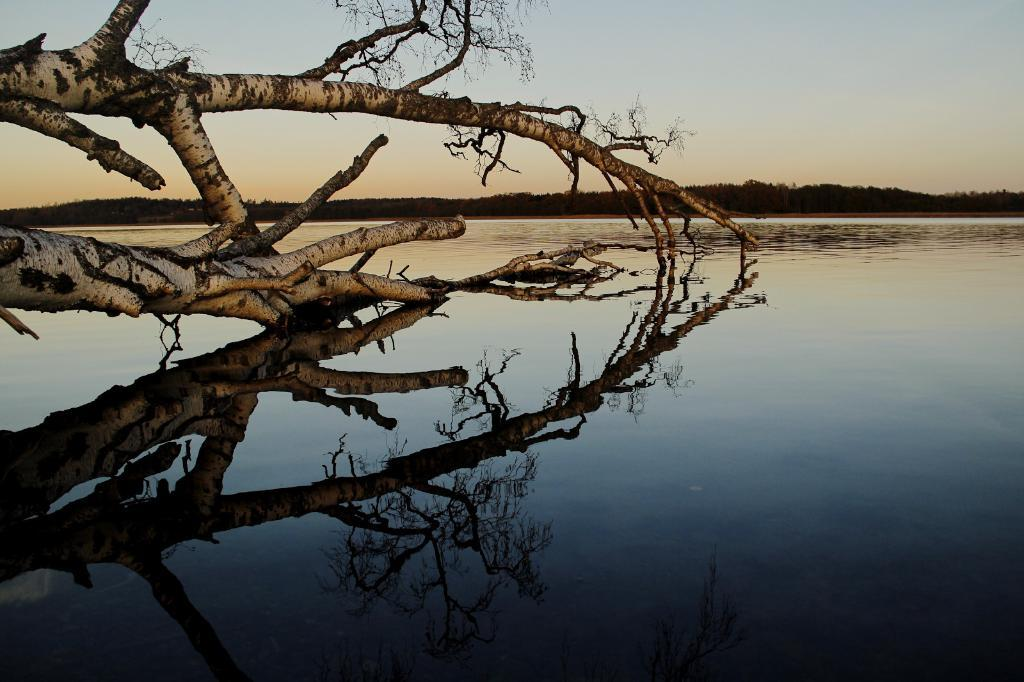What is the main object or feature in the image? There is a tree in the image. What is located at the bottom of the image? There is water at the bottom of the image. What can be seen in the background of the image? There are many trees and plants in the background of the image. What is visible at the top of the image? The sky is visible at the top of the image. How does the love between the trees manifest in the image? There is no indication of love between the trees in the image; it simply shows a tree and its surroundings. 